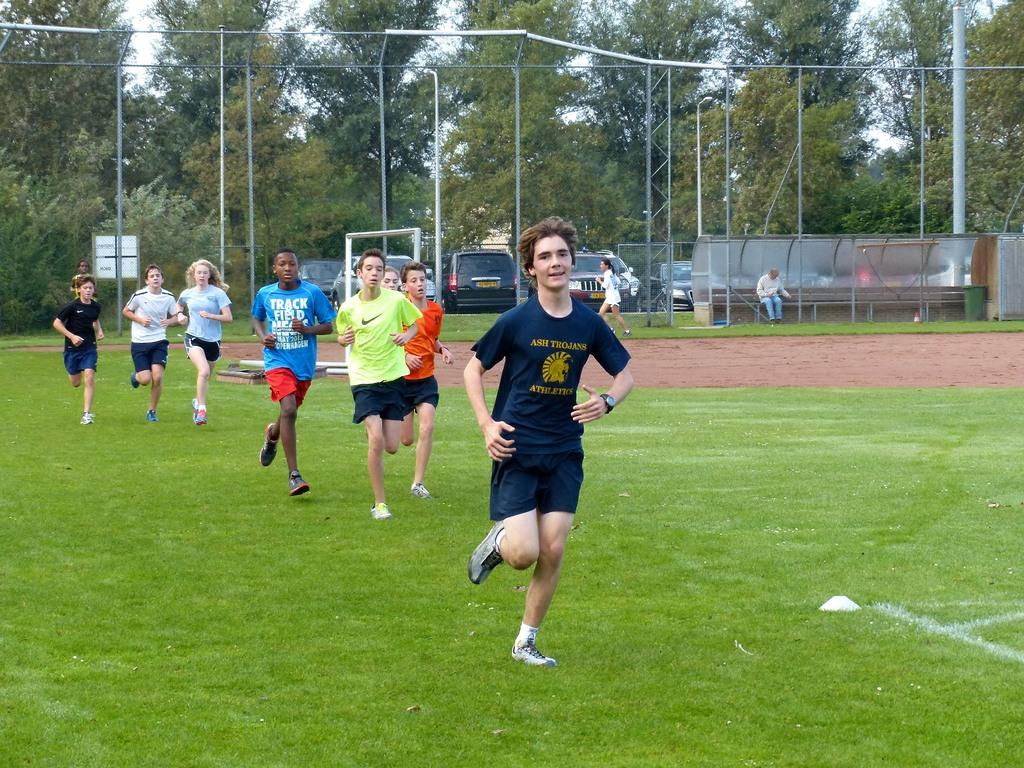<image>
Render a clear and concise summary of the photo. A young man is wearing a shirt with the word ash on it. 